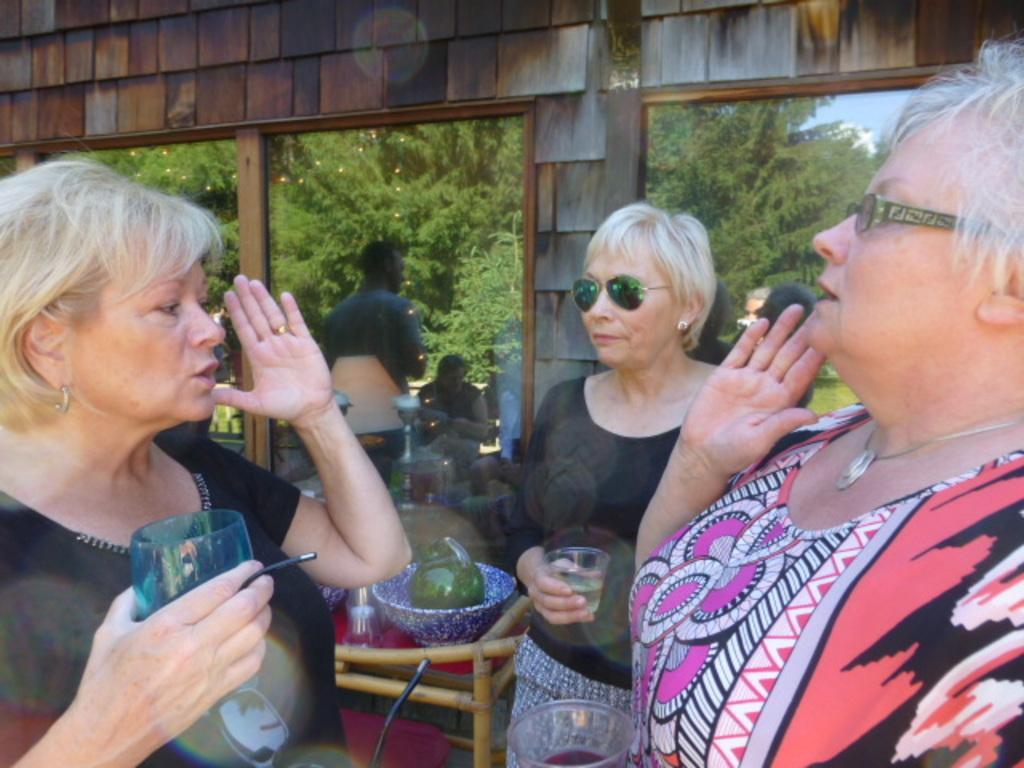In one or two sentences, can you explain what this image depicts? In this image I can see the group of people with different color dresses. I can see few people are wearing the specs and goggles. And two people are holding the glasses. In the back can see the bowl and glass on the chair. In the background I can see many trees and the sky. 